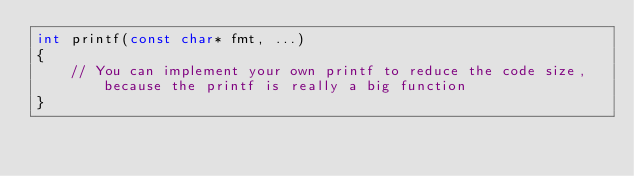<code> <loc_0><loc_0><loc_500><loc_500><_C_>int printf(const char* fmt, ...)
{
    // You can implement your own printf to reduce the code size, because the printf is really a big function
}

</code> 